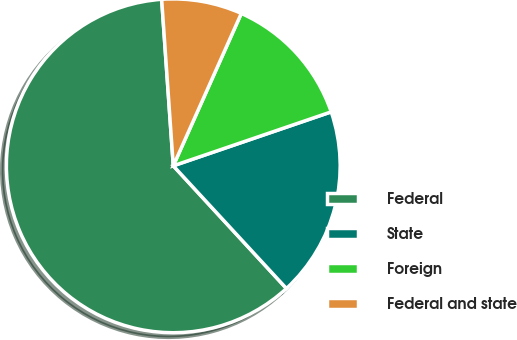Convert chart. <chart><loc_0><loc_0><loc_500><loc_500><pie_chart><fcel>Federal<fcel>State<fcel>Foreign<fcel>Federal and state<nl><fcel>60.75%<fcel>18.38%<fcel>13.08%<fcel>7.79%<nl></chart> 